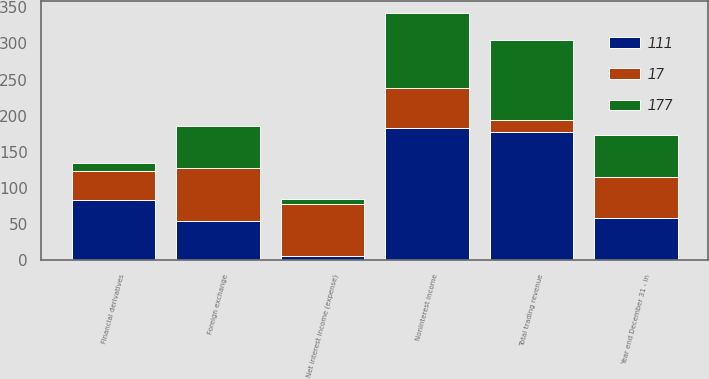Convert chart to OTSL. <chart><loc_0><loc_0><loc_500><loc_500><stacked_bar_chart><ecel><fcel>Year end December 31 - in<fcel>Net interest income (expense)<fcel>Noninterest income<fcel>Total trading revenue<fcel>Foreign exchange<fcel>Financial derivatives<nl><fcel>17<fcel>58<fcel>72<fcel>55<fcel>17<fcel>73<fcel>39<nl><fcel>177<fcel>58<fcel>7<fcel>104<fcel>111<fcel>58<fcel>12<nl><fcel>111<fcel>58<fcel>6<fcel>183<fcel>177<fcel>55<fcel>84<nl></chart> 